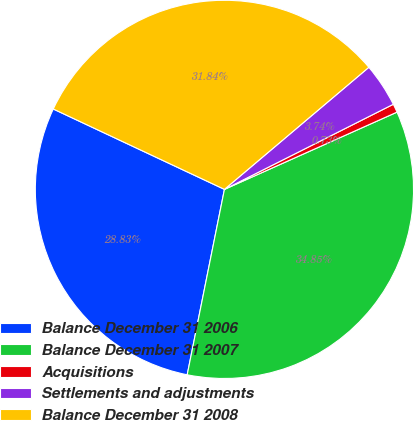Convert chart. <chart><loc_0><loc_0><loc_500><loc_500><pie_chart><fcel>Balance December 31 2006<fcel>Balance December 31 2007<fcel>Acquisitions<fcel>Settlements and adjustments<fcel>Balance December 31 2008<nl><fcel>28.83%<fcel>34.85%<fcel>0.73%<fcel>3.74%<fcel>31.84%<nl></chart> 